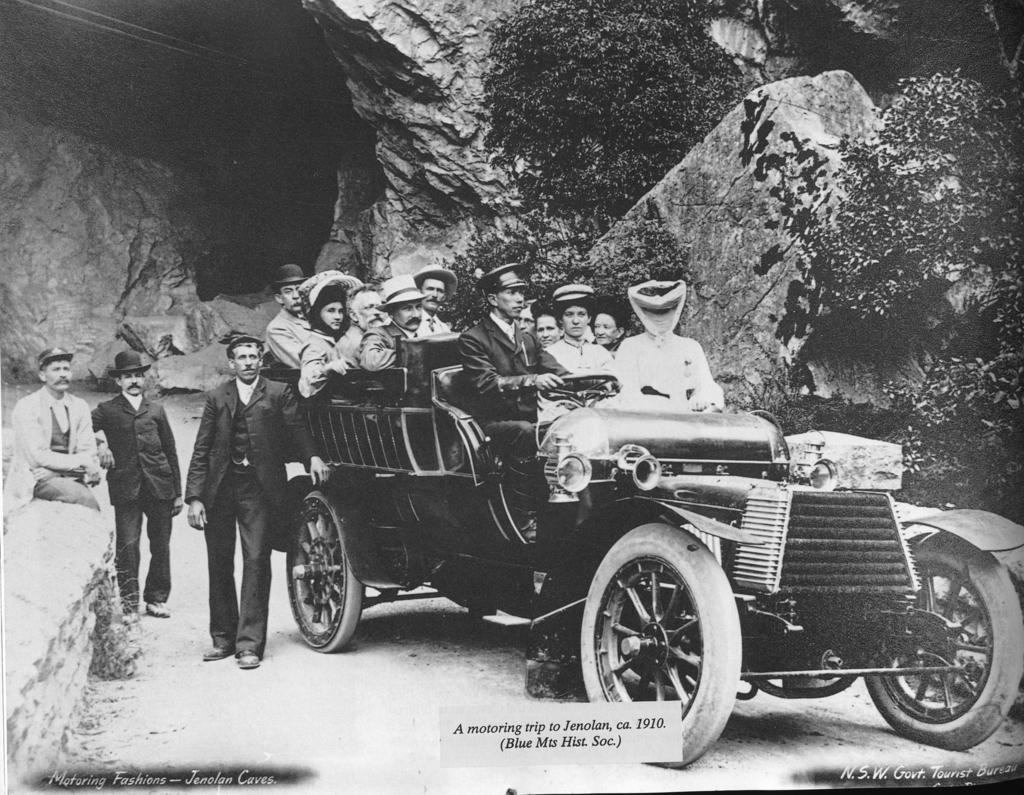What is the color scheme of the image? The image is black and white. What can be seen in the image? There is a group of people in the image. Where are the people located in the image? The people are on a vehicle. What can be seen in the background of the image? There are rocks and trees in the background of the image. Is there a veil covering any part of the image? There is no veil present in the image. Can you see a basketball game happening in the image? There is no basketball game present in the image. 